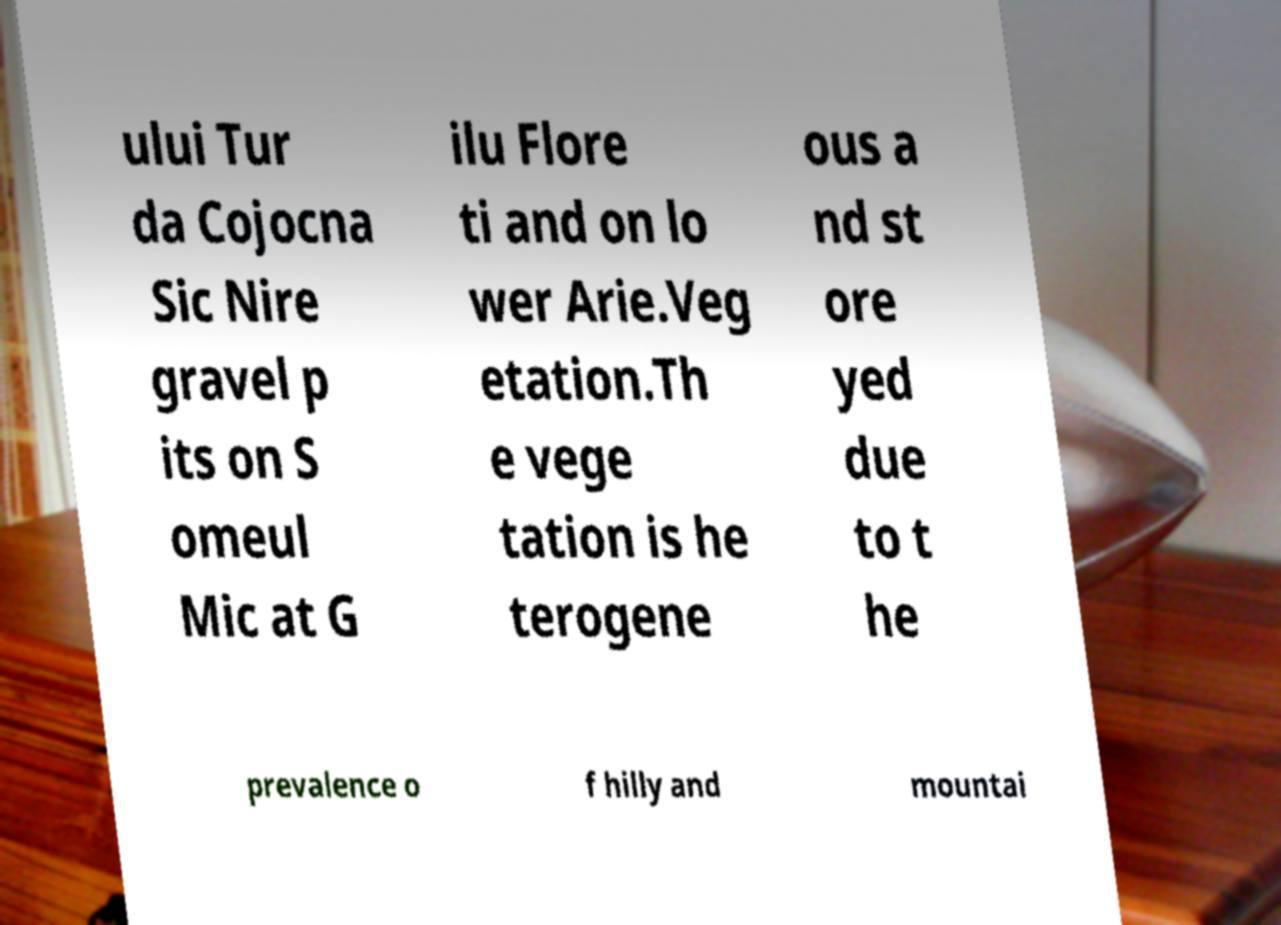Could you extract and type out the text from this image? ului Tur da Cojocna Sic Nire gravel p its on S omeul Mic at G ilu Flore ti and on lo wer Arie.Veg etation.Th e vege tation is he terogene ous a nd st ore yed due to t he prevalence o f hilly and mountai 